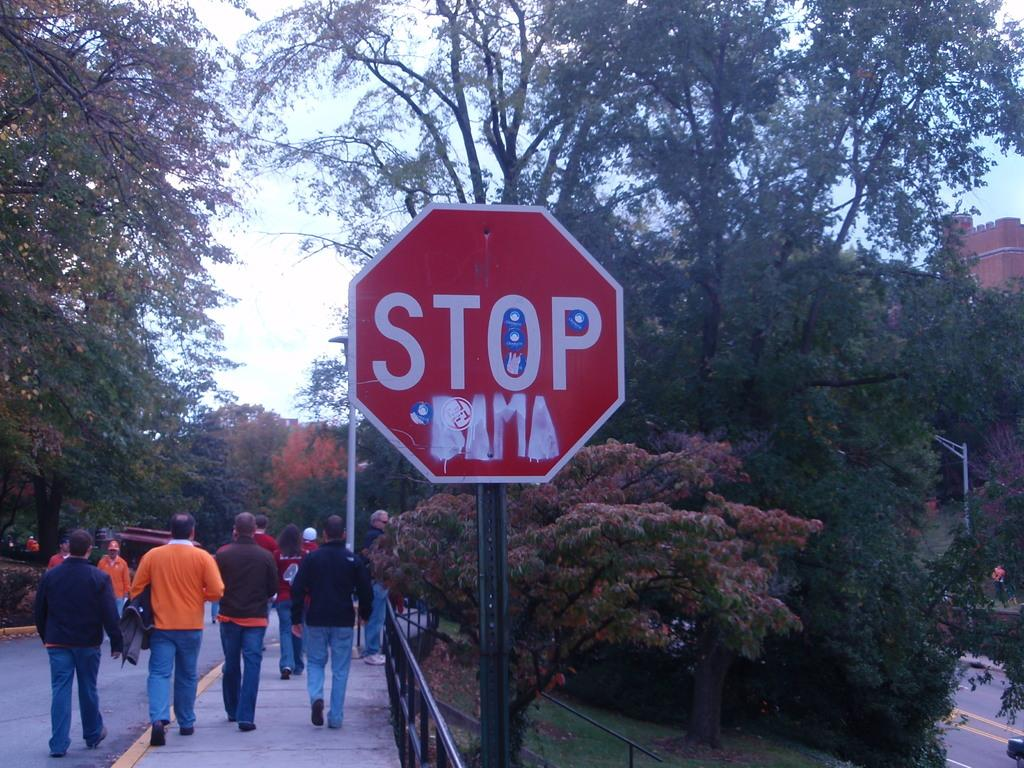<image>
Provide a brief description of the given image. Several people walking alongside a hexagonal Stop sign. 